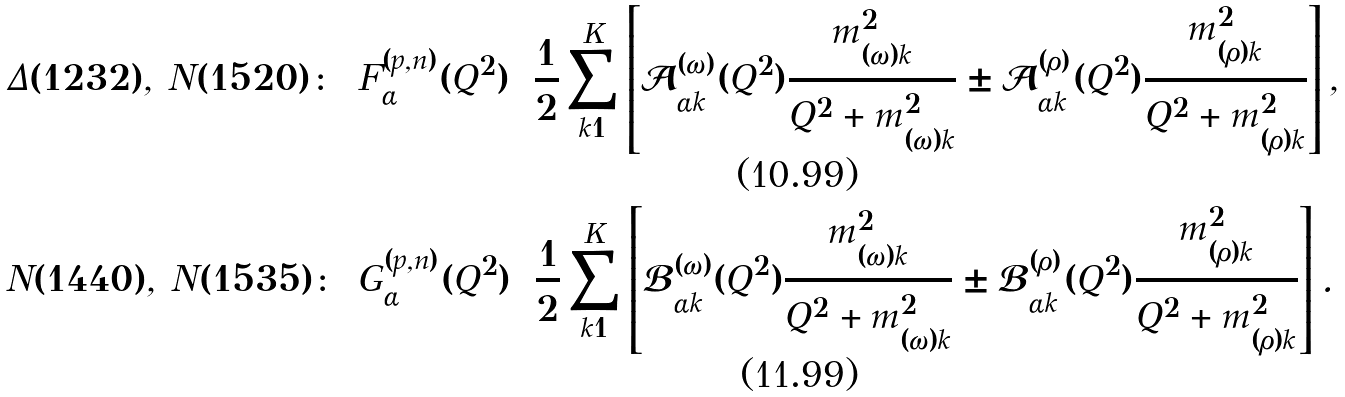<formula> <loc_0><loc_0><loc_500><loc_500>& \Delta ( 1 2 3 2 ) , \, N ( 1 5 2 0 ) \colon & & F ^ { ( p , n ) } _ { \alpha } ( Q ^ { 2 } ) = \frac { 1 } { 2 } \sum _ { k = 1 } ^ { K } \left [ \mathcal { A } ^ { ( \omega ) } _ { \alpha k } ( Q ^ { 2 } ) \frac { m _ { ( \omega ) k } ^ { 2 } } { Q ^ { 2 } + m _ { ( \omega ) k } ^ { 2 } } \pm \mathcal { A } ^ { ( \rho ) } _ { \alpha k } ( Q ^ { 2 } ) \frac { m _ { ( \rho ) k } ^ { 2 } } { Q ^ { 2 } + m _ { ( \rho ) k } ^ { 2 } } \right ] , \\ & N ( 1 4 4 0 ) , \, N ( 1 5 3 5 ) \colon & & G ^ { ( p , n ) } _ { \alpha } ( Q ^ { 2 } ) = \frac { 1 } { 2 } \sum _ { k = 1 } ^ { K } \left [ \mathcal { B } ^ { ( \omega ) } _ { \alpha k } ( Q ^ { 2 } ) \frac { m _ { ( \omega ) k } ^ { 2 } } { Q ^ { 2 } + m _ { ( \omega ) k } ^ { 2 } } \pm \mathcal { B } ^ { ( \rho ) } _ { \alpha k } ( Q ^ { 2 } ) \frac { m _ { ( \rho ) k } ^ { 2 } } { Q ^ { 2 } + m _ { ( \rho ) k } ^ { 2 } } \right ] .</formula> 